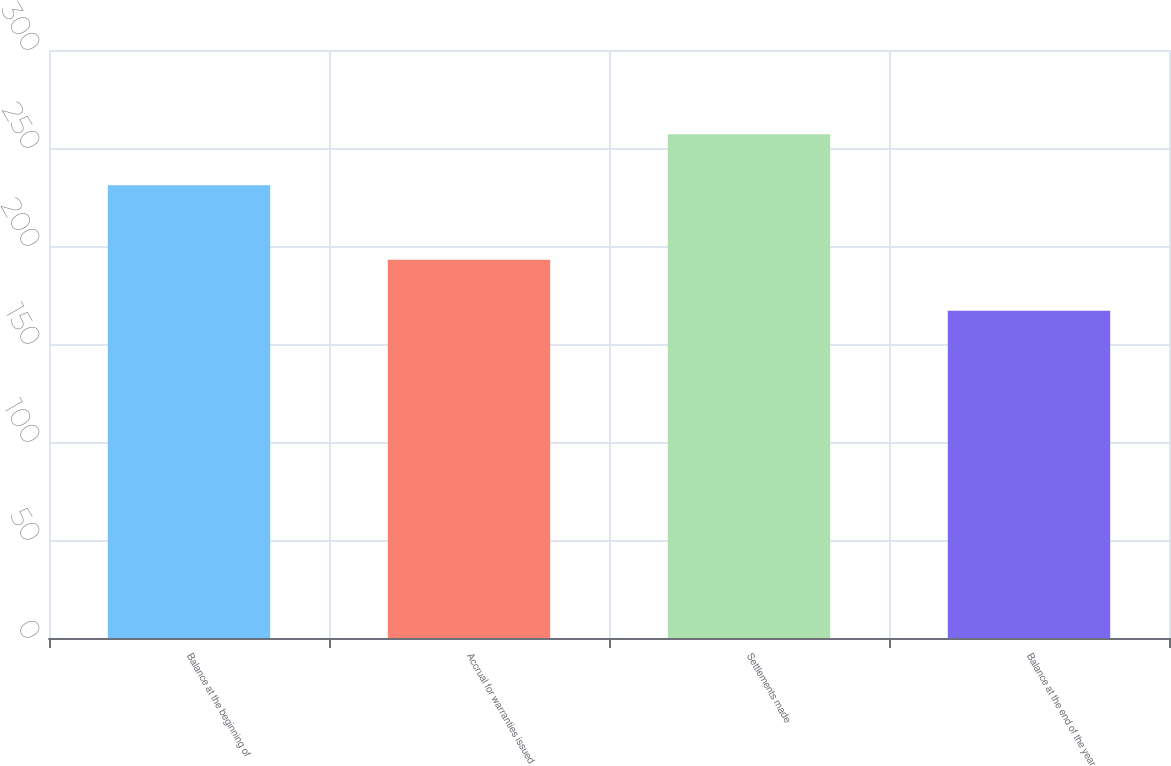Convert chart to OTSL. <chart><loc_0><loc_0><loc_500><loc_500><bar_chart><fcel>Balance at the beginning of<fcel>Accrual for warranties issued<fcel>Settlements made<fcel>Balance at the end of the year<nl><fcel>231<fcel>193<fcel>257<fcel>167<nl></chart> 